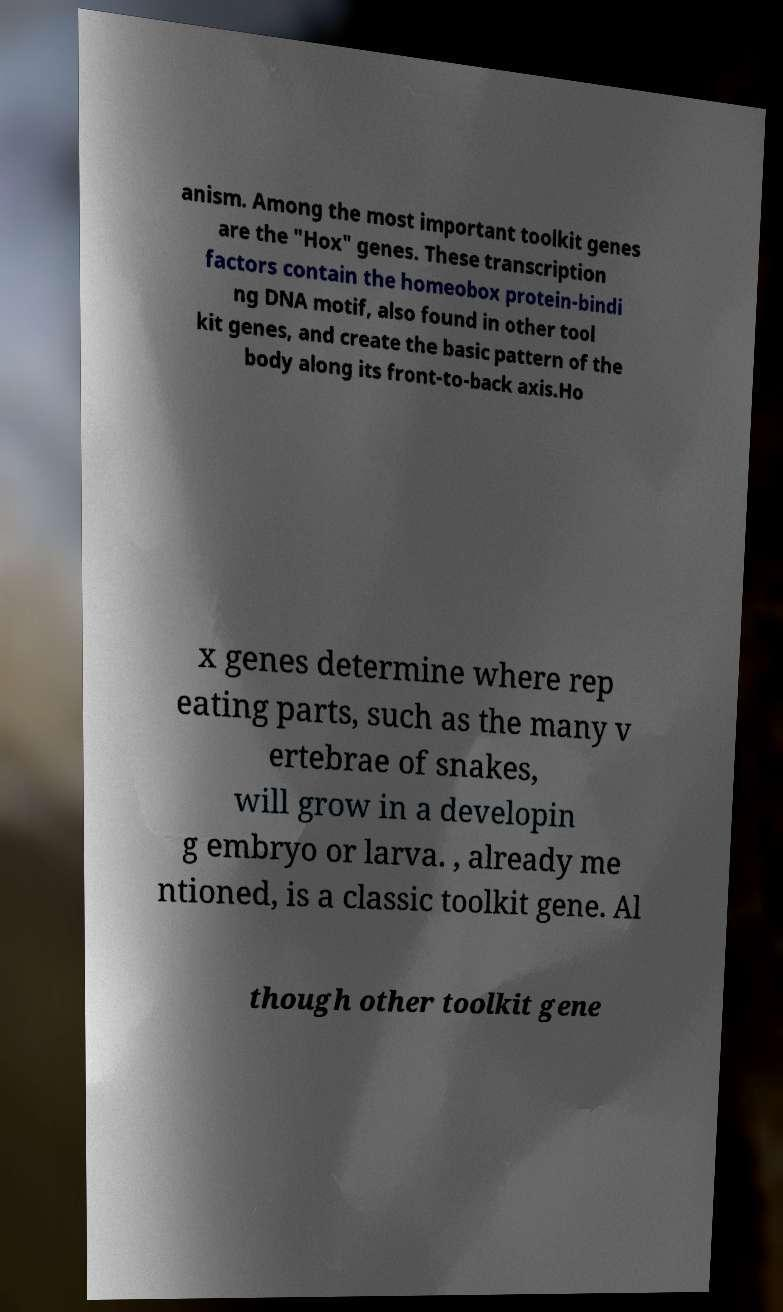For documentation purposes, I need the text within this image transcribed. Could you provide that? anism. Among the most important toolkit genes are the "Hox" genes. These transcription factors contain the homeobox protein-bindi ng DNA motif, also found in other tool kit genes, and create the basic pattern of the body along its front-to-back axis.Ho x genes determine where rep eating parts, such as the many v ertebrae of snakes, will grow in a developin g embryo or larva. , already me ntioned, is a classic toolkit gene. Al though other toolkit gene 